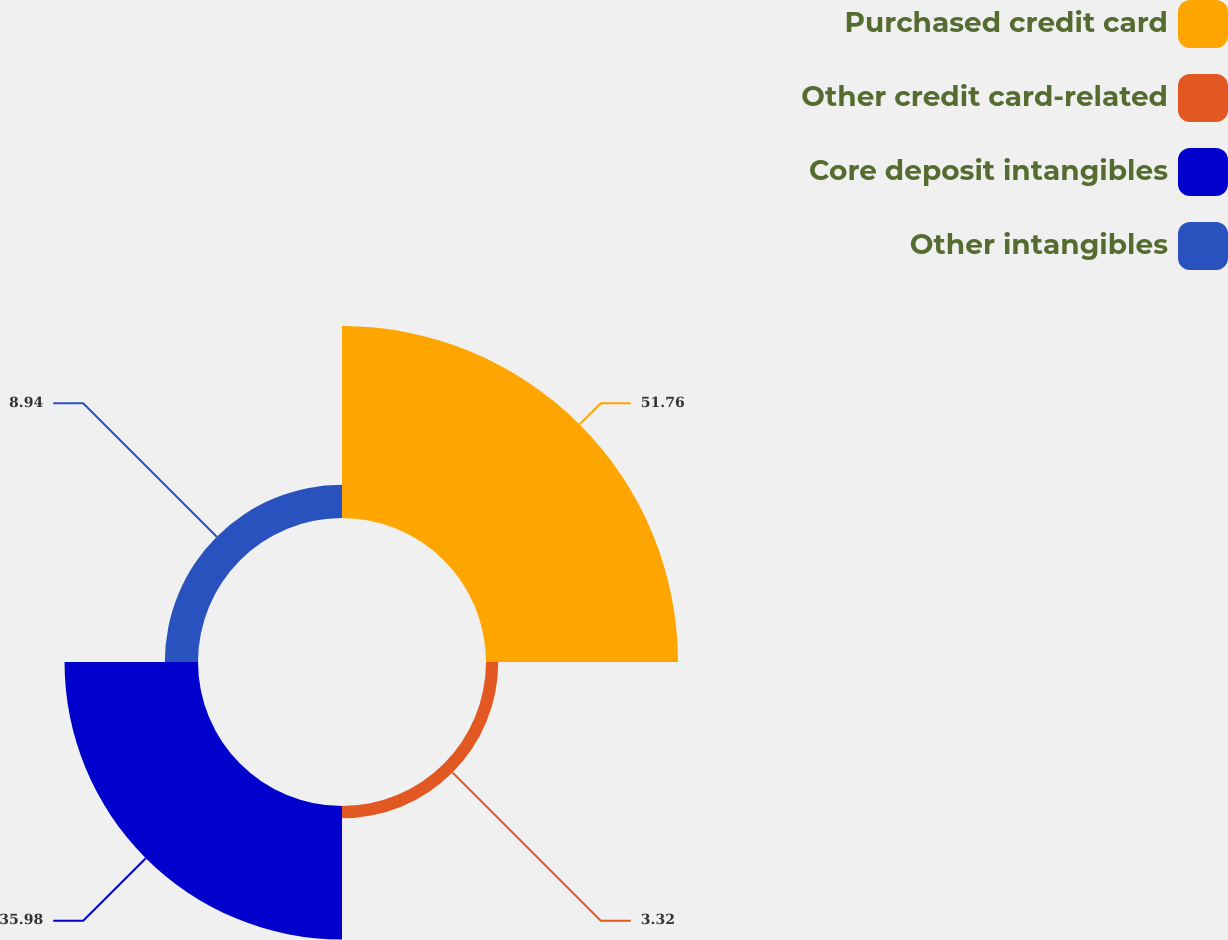Convert chart to OTSL. <chart><loc_0><loc_0><loc_500><loc_500><pie_chart><fcel>Purchased credit card<fcel>Other credit card-related<fcel>Core deposit intangibles<fcel>Other intangibles<nl><fcel>51.76%<fcel>3.32%<fcel>35.98%<fcel>8.94%<nl></chart> 